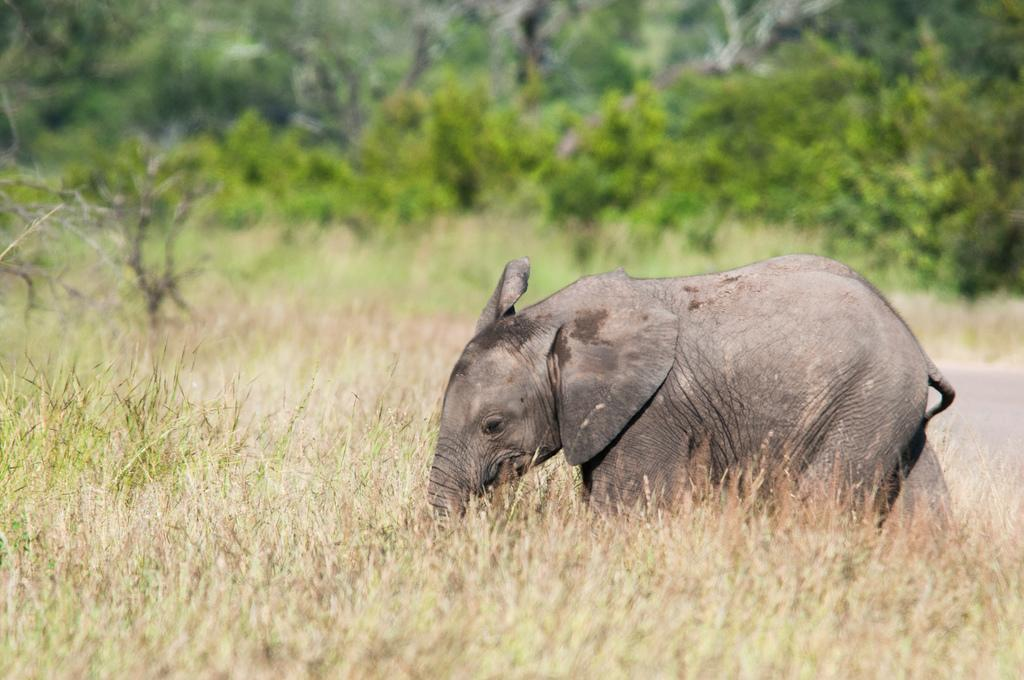What is the main subject in the center of the image? There is an elephant in the center of the image. What can be seen in the background of the image? There are trees and grass in the background of the image. What type of powder is the elephant using to perform a trick in the image? There is no powder or trick being performed by the elephant in the image. 